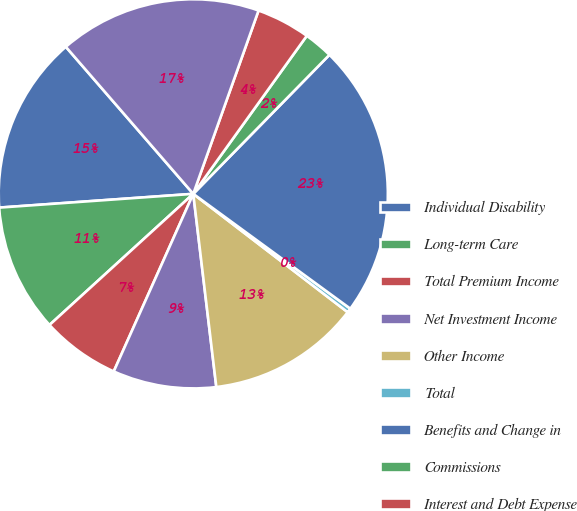Convert chart to OTSL. <chart><loc_0><loc_0><loc_500><loc_500><pie_chart><fcel>Individual Disability<fcel>Long-term Care<fcel>Total Premium Income<fcel>Net Investment Income<fcel>Other Income<fcel>Total<fcel>Benefits and Change in<fcel>Commissions<fcel>Interest and Debt Expense<fcel>Other Expenses<nl><fcel>14.76%<fcel>10.64%<fcel>6.53%<fcel>8.59%<fcel>12.7%<fcel>0.36%<fcel>22.71%<fcel>2.42%<fcel>4.47%<fcel>16.81%<nl></chart> 